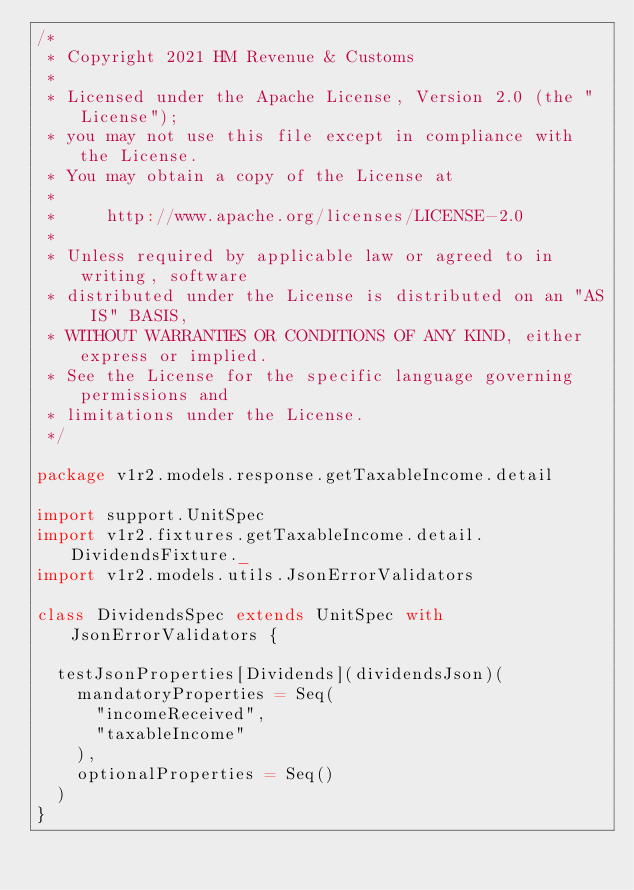Convert code to text. <code><loc_0><loc_0><loc_500><loc_500><_Scala_>/*
 * Copyright 2021 HM Revenue & Customs
 *
 * Licensed under the Apache License, Version 2.0 (the "License");
 * you may not use this file except in compliance with the License.
 * You may obtain a copy of the License at
 *
 *     http://www.apache.org/licenses/LICENSE-2.0
 *
 * Unless required by applicable law or agreed to in writing, software
 * distributed under the License is distributed on an "AS IS" BASIS,
 * WITHOUT WARRANTIES OR CONDITIONS OF ANY KIND, either express or implied.
 * See the License for the specific language governing permissions and
 * limitations under the License.
 */

package v1r2.models.response.getTaxableIncome.detail

import support.UnitSpec
import v1r2.fixtures.getTaxableIncome.detail.DividendsFixture._
import v1r2.models.utils.JsonErrorValidators

class DividendsSpec extends UnitSpec with JsonErrorValidators {

  testJsonProperties[Dividends](dividendsJson)(
    mandatoryProperties = Seq(
      "incomeReceived",
      "taxableIncome"
    ),
    optionalProperties = Seq()
  )
}</code> 